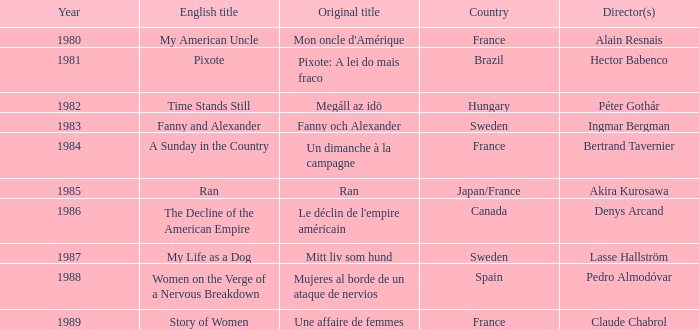What was the year of Megáll az Idö? 1982.0. 